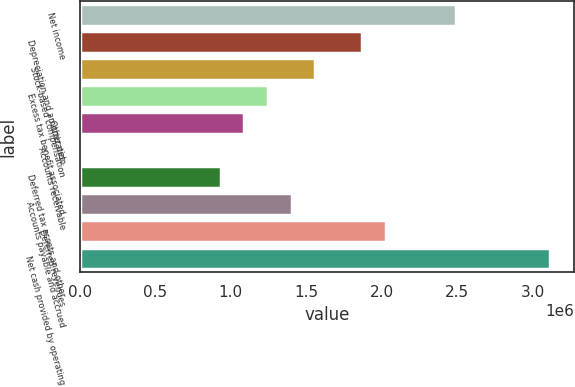<chart> <loc_0><loc_0><loc_500><loc_500><bar_chart><fcel>Net income<fcel>Depreciation and amortization<fcel>Stock-based compensation<fcel>Excess tax benefit associated<fcel>Other net<fcel>Accounts receivable<fcel>Deferred tax assets and other<fcel>Accounts payable and accrued<fcel>Deferred revenues<fcel>Net cash provided by operating<nl><fcel>2.49525e+06<fcel>1.8715e+06<fcel>1.55963e+06<fcel>1.24775e+06<fcel>1.09181e+06<fcel>251<fcel>935877<fcel>1.40369e+06<fcel>2.02744e+06<fcel>3.119e+06<nl></chart> 